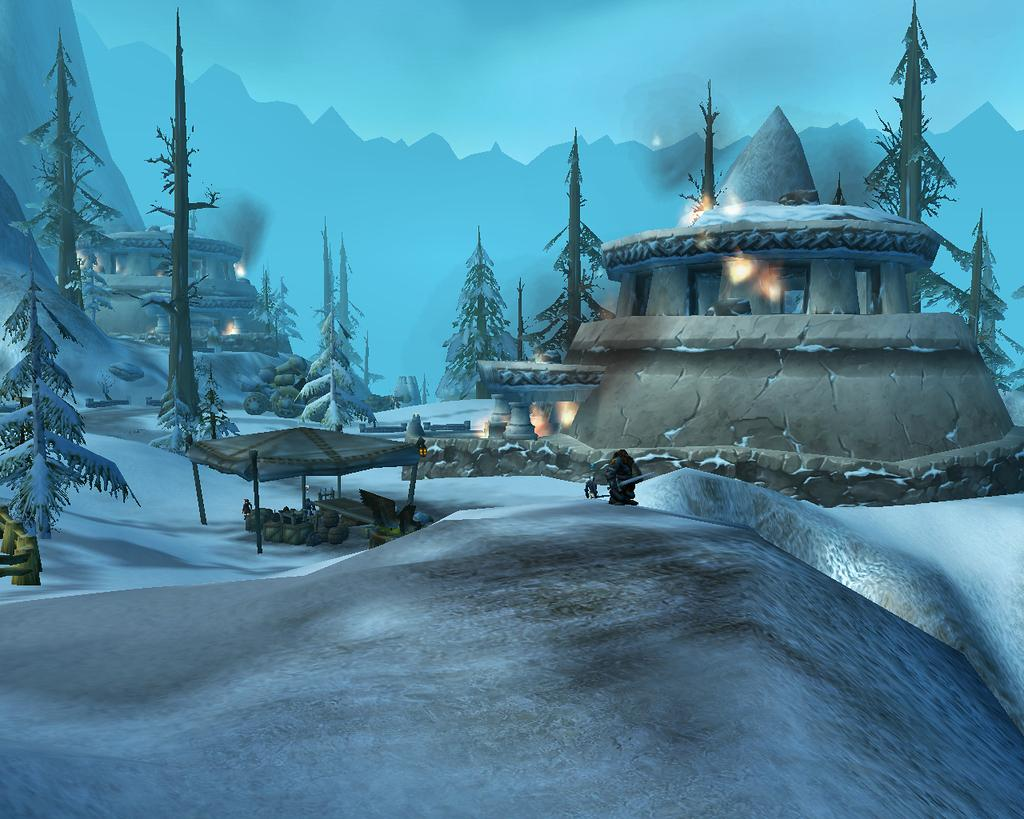What type of structures can be seen in the image? The image contains houses. What can be seen illuminating the scene in the image? There are lights visible in the image. What is the condition of the trees in the image? Trees covered with snow are present in the image. What is visible in the background of the image? There is a mountain and the sky visible in the background of the image. What type of dust can be seen on the roofs of the houses in the image? There is no dust visible on the roofs of the houses in the image. 